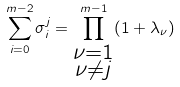<formula> <loc_0><loc_0><loc_500><loc_500>\sum _ { i = 0 } ^ { m - 2 } \sigma _ { i } ^ { j } = \prod _ { \substack { \nu = 1 \\ \nu \neq j } } ^ { m - 1 } ( 1 + \lambda _ { \nu } )</formula> 